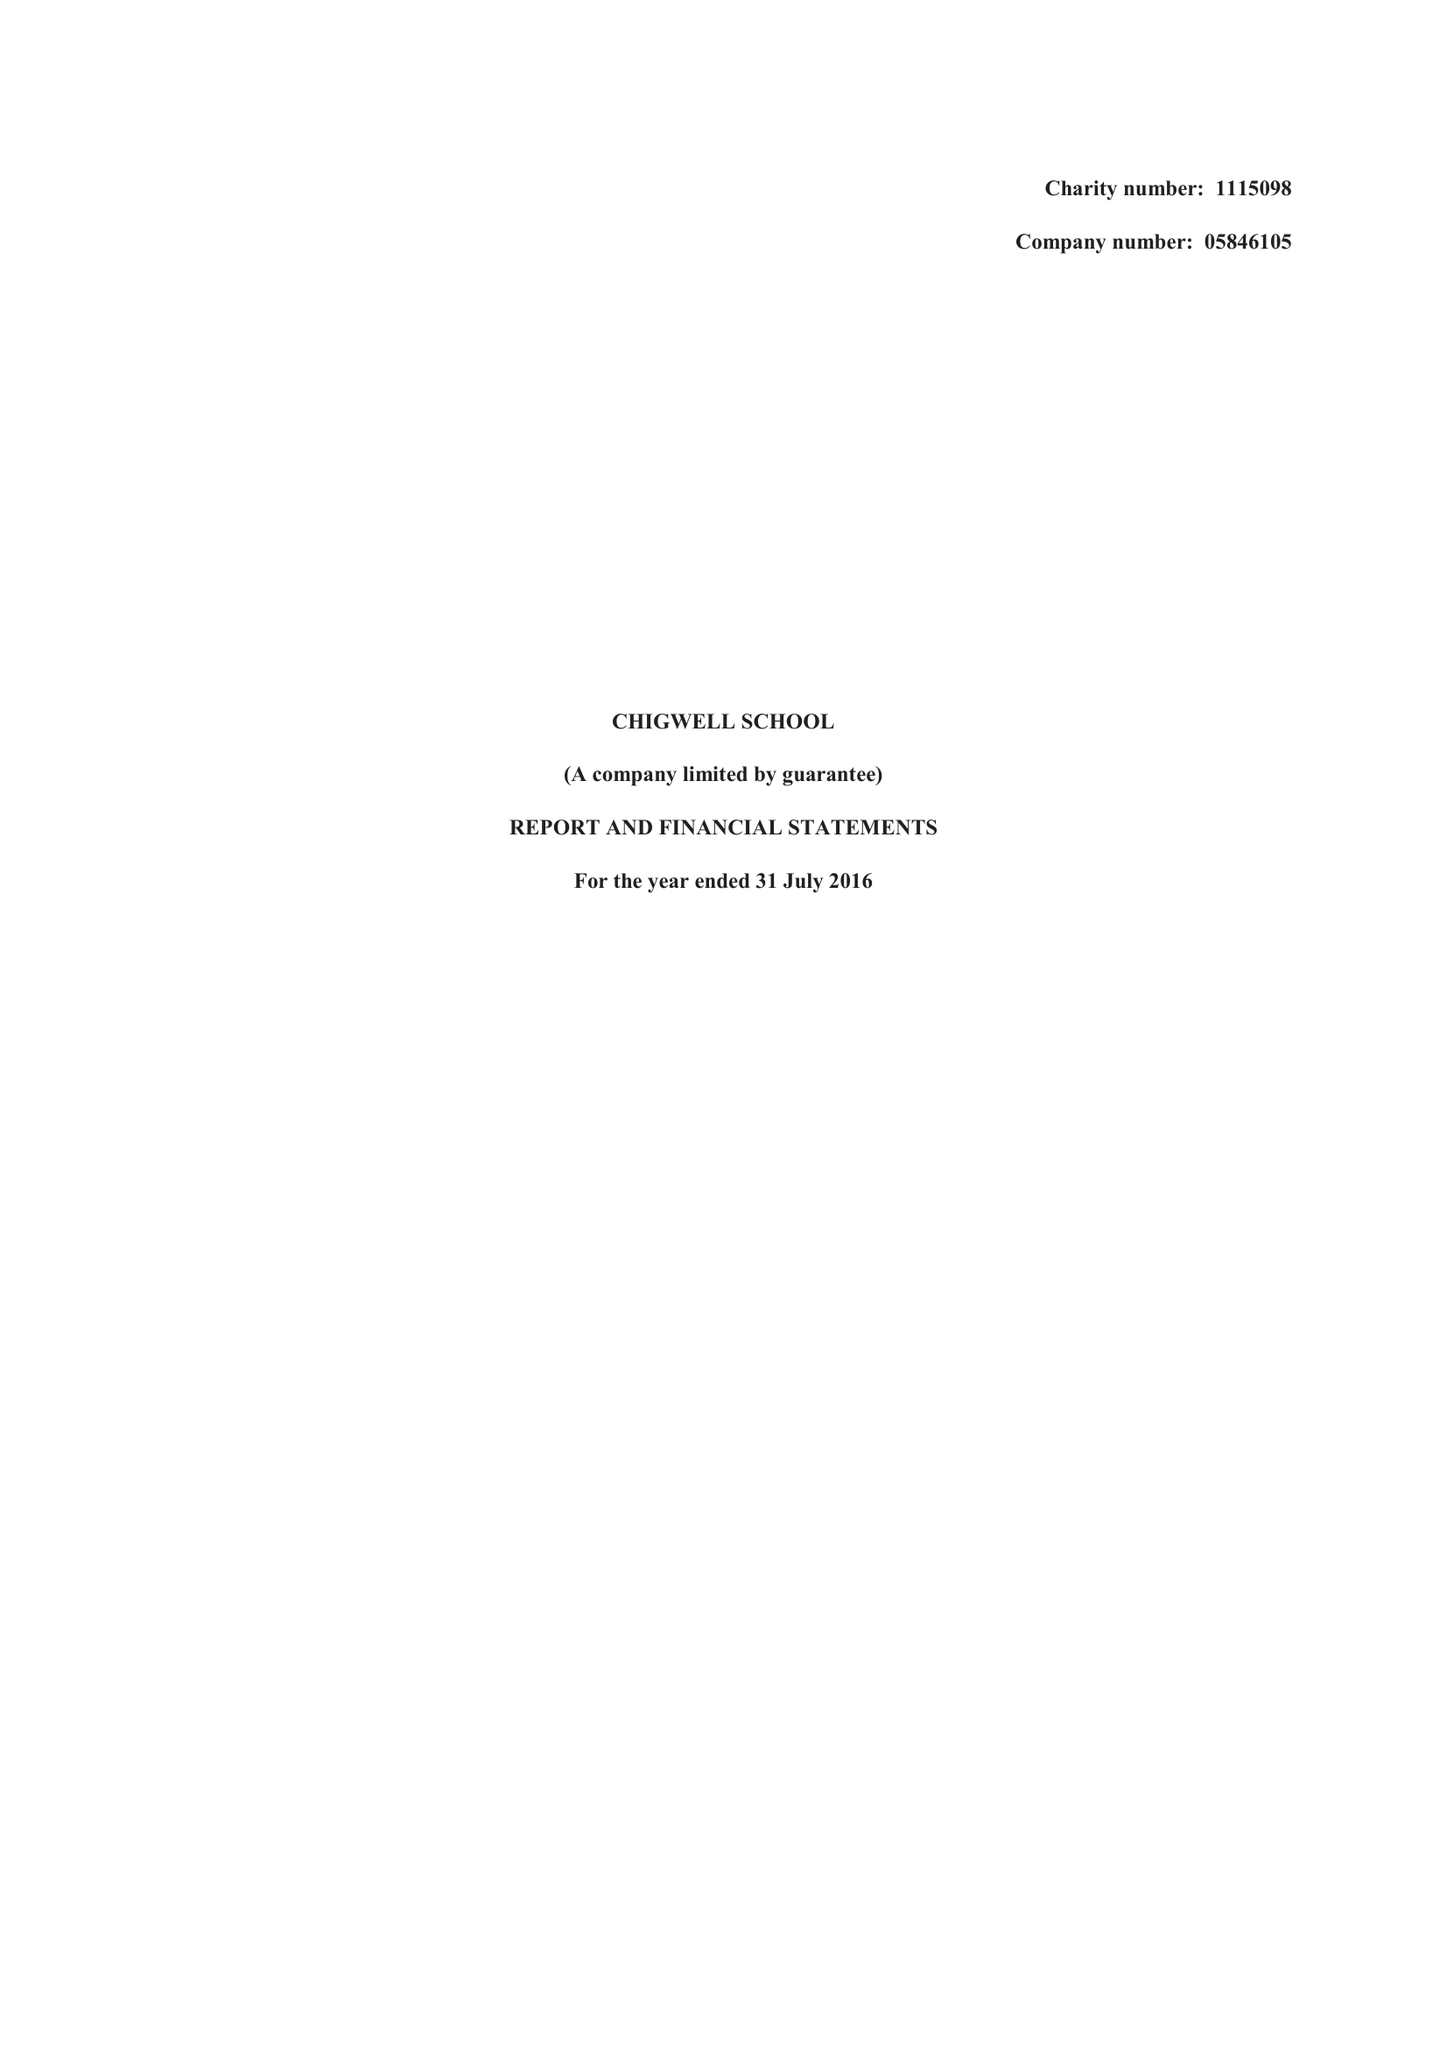What is the value for the address__post_town?
Answer the question using a single word or phrase. CHIGWELL 